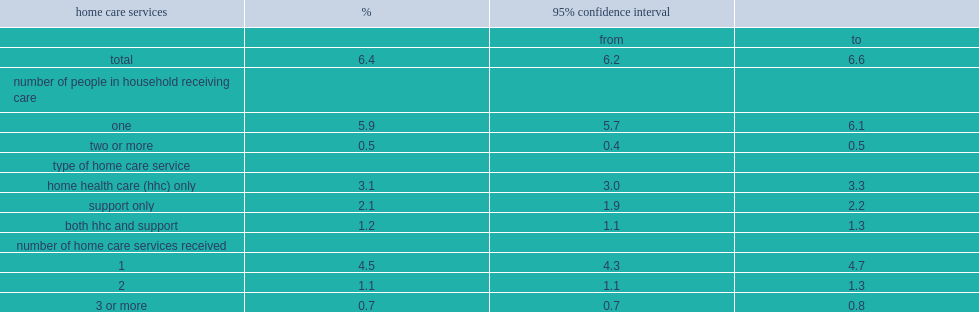Parse the table in full. {'header': ['home care services', '%', '95% confidence interval', ''], 'rows': [['', '', 'from', 'to'], ['total', '6.4', '6.2', '6.6'], ['number of people in household receiving care', '', '', ''], ['one', '5.9', '5.7', '6.1'], ['two or more', '0.5', '0.4', '0.5'], ['type of home care service', '', '', ''], ['home health care (hhc) only', '3.1', '3.0', '3.3'], ['support only', '2.1', '1.9', '2.2'], ['both hhc and support', '1.2', '1.1', '1.3'], ['number of home care services received', '', '', ''], ['1', '4.5', '4.3', '4.7'], ['2', '1.1', '1.1', '1.3'], ['3 or more', '0.7', '0.7', '0.8']]} In 2015/2016, what was the percentage of canadian households reporting that at least one person received formal home care services? 6.4. What was the precentage of canadian households where one person received home care services in 2015/2016? 5.9. What was the precentage of canadian households where two or more people received home care services in 2015/2016? 0.5. What was the precentage of canadian households where only one type of home care service was received in 2015/2016? 4.5. 